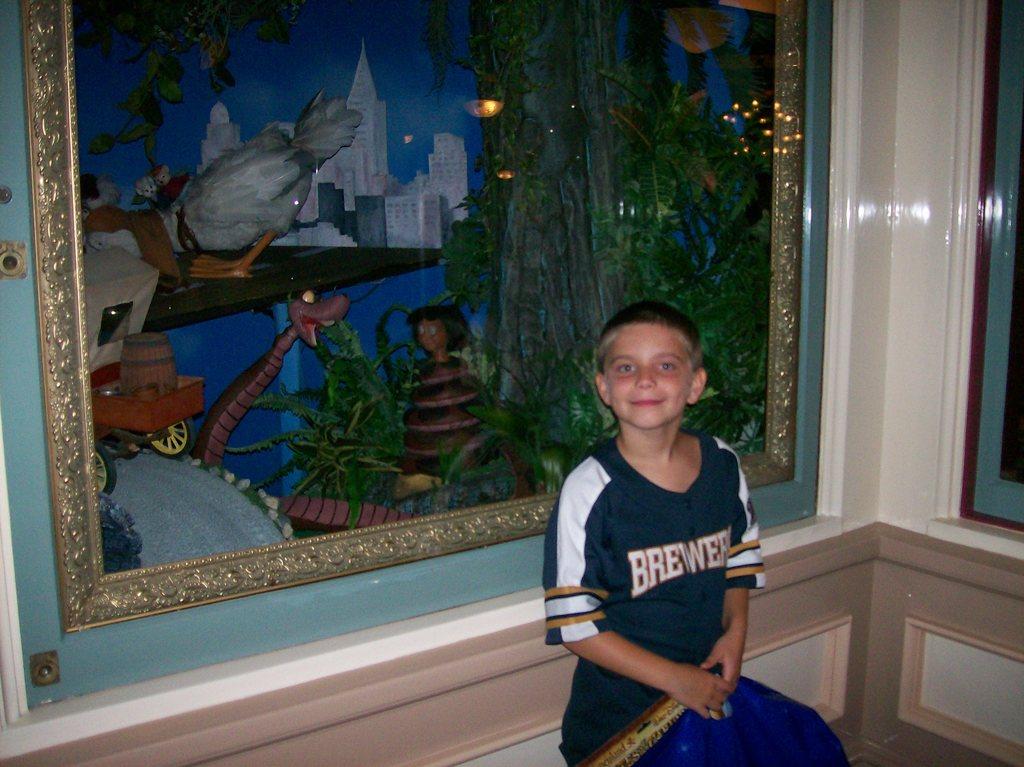What is the name of the shirt the kid's wearing?
Your answer should be compact. Brewers. 